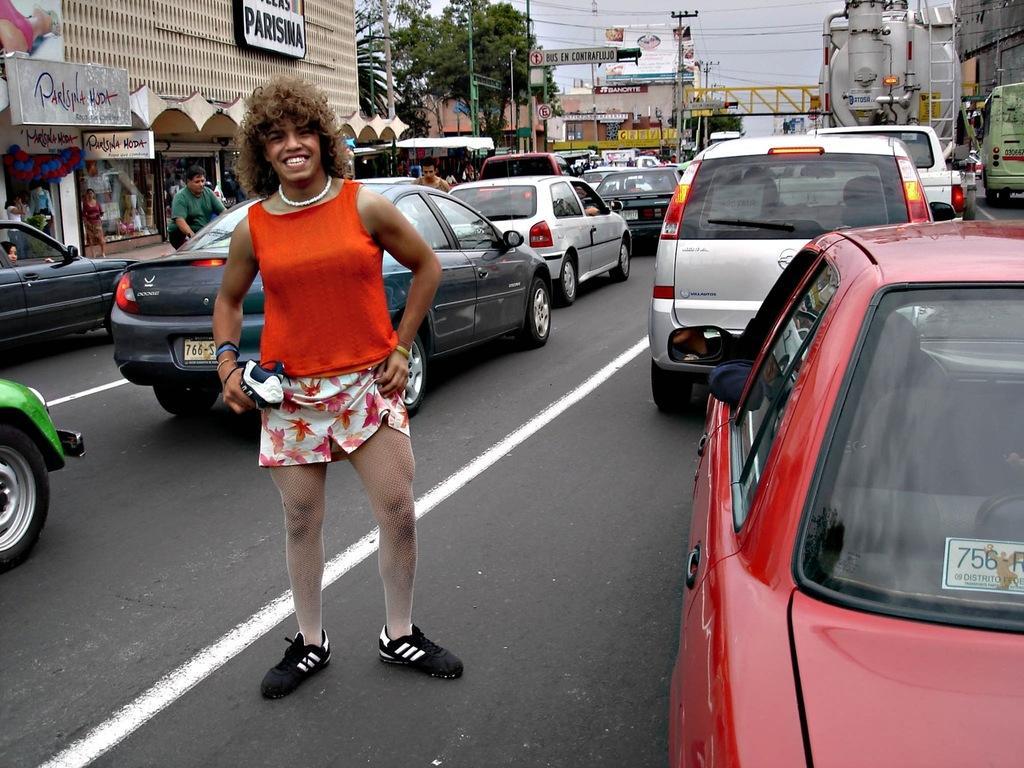Please provide a concise description of this image. In this image there is a woman standing in the road and the back ground there is car, bridge, building , tree , sky, pole , light. 